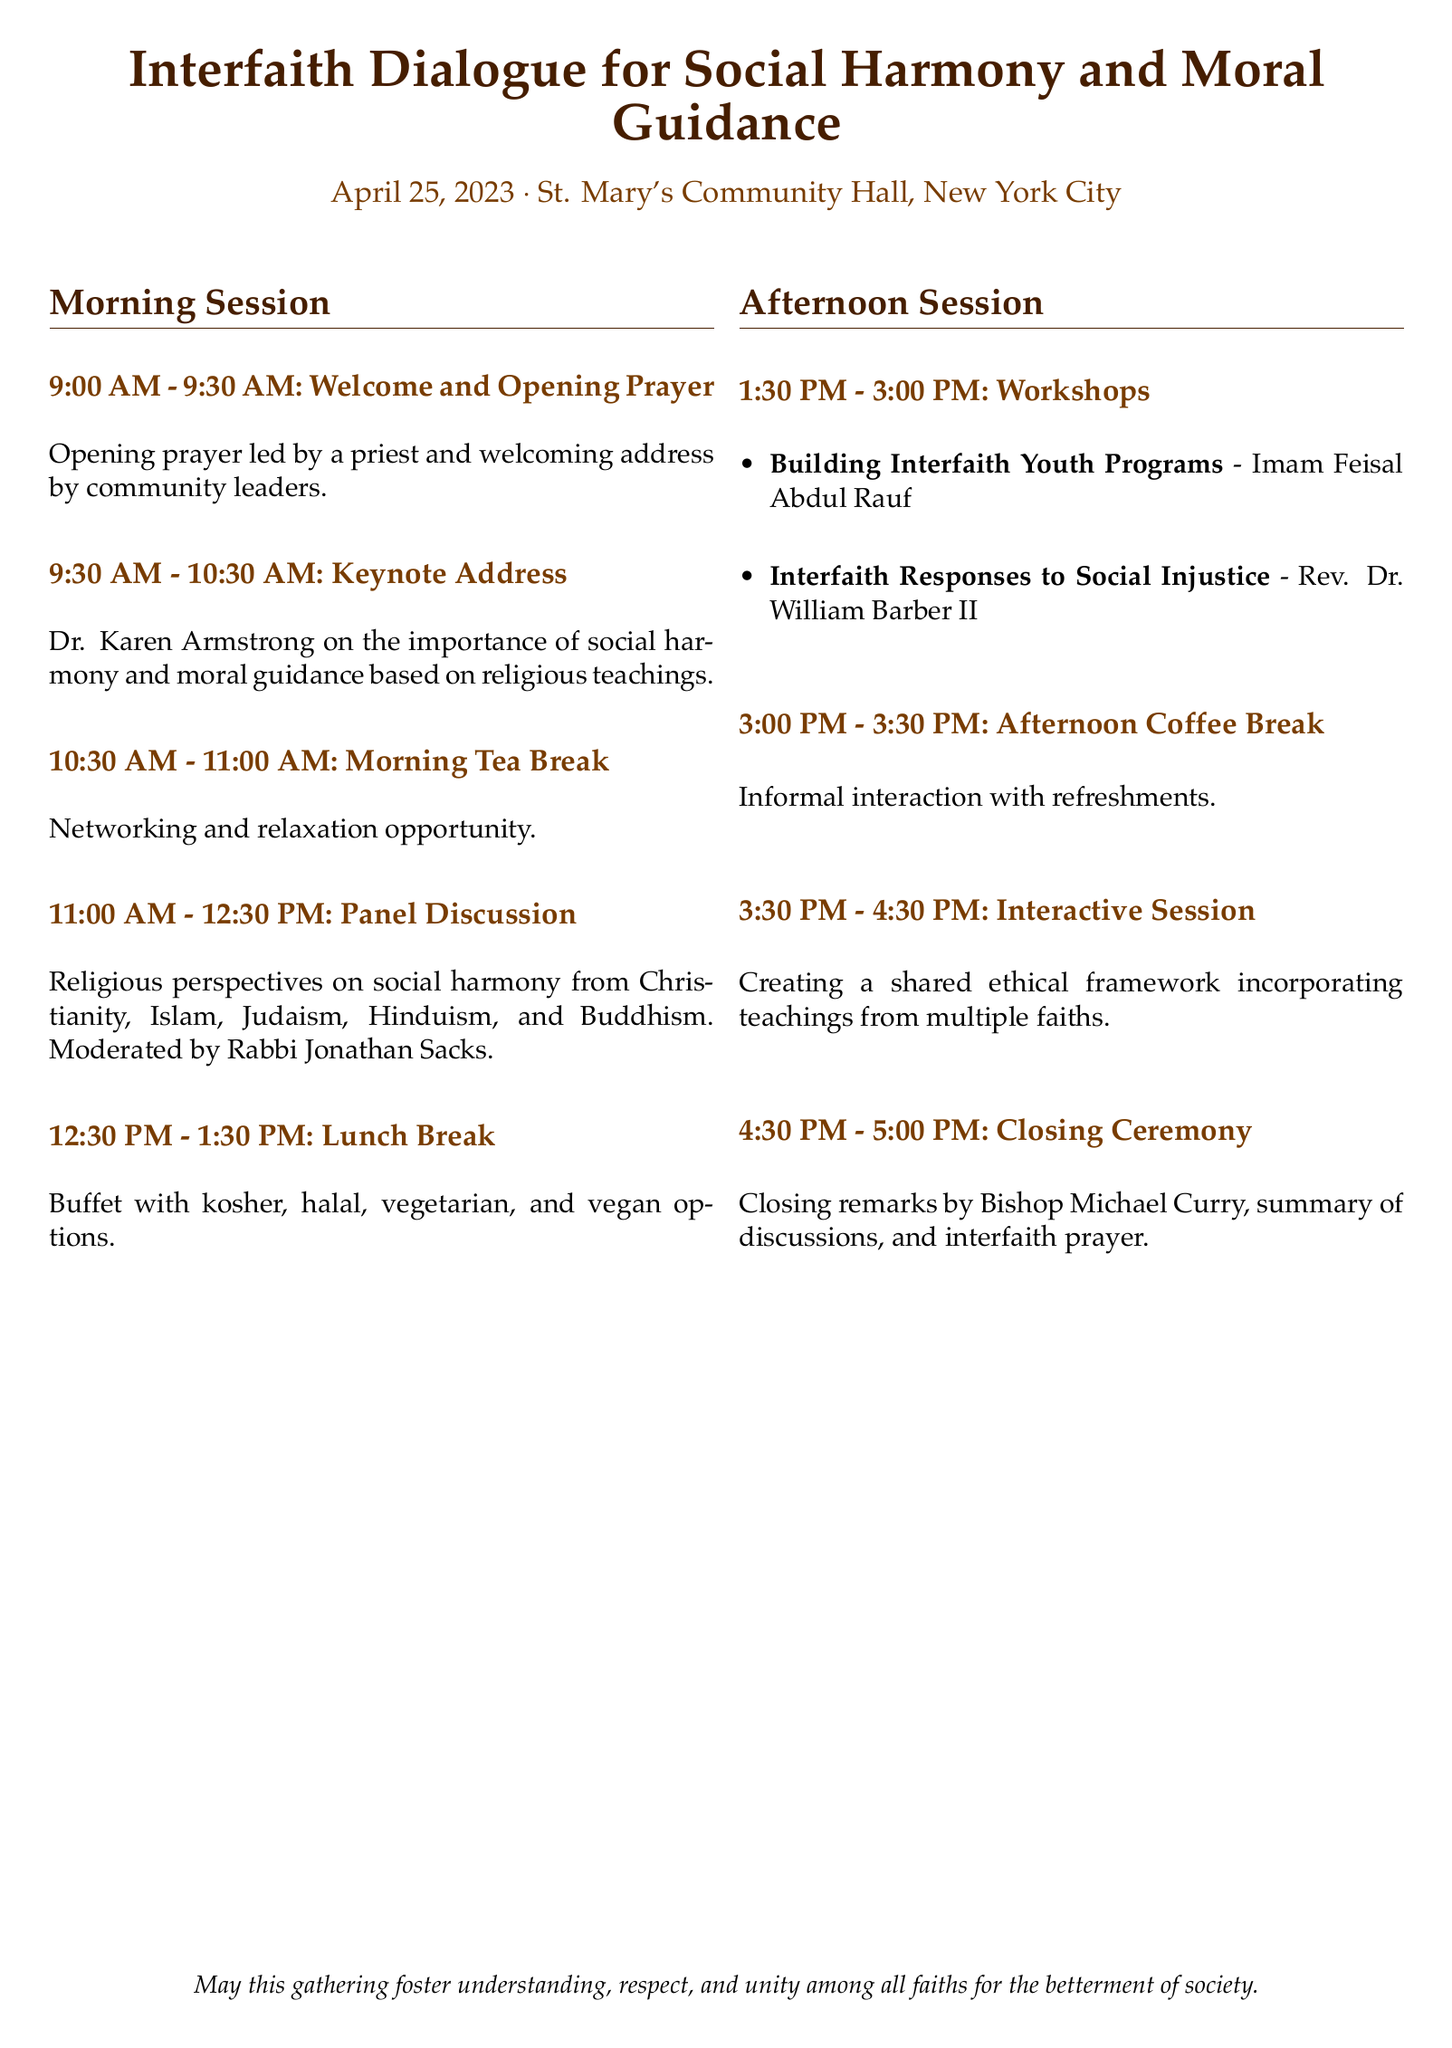What is the date of the event? The date of the event is clearly stated in the document as April 25, 2023.
Answer: April 25, 2023 Who is giving the keynote address? The document specifically names Dr. Karen Armstrong as the speaker for the keynote address.
Answer: Dr. Karen Armstrong What time does the morning tea break start? The start time for the morning tea break can be found in the schedule as 10:30 AM.
Answer: 10:30 AM How many workshops are scheduled for the afternoon session? The document mentions two workshops scheduled in the afternoon session.
Answer: Two Who is moderating the panel discussion? The panel discussion is moderated by Rabbi Jonathan Sacks, as indicated in the itinerary.
Answer: Rabbi Jonathan Sacks What is the main focus of the interactive session? The focus of the interactive session is about creating a shared ethical framework, as stated in the document.
Answer: Creating a shared ethical framework What types of food are offered during the lunch break? The document lists the types of food options available during lunch as kosher, halal, vegetarian, and vegan.
Answer: Kosher, halal, vegetarian, vegan Who is delivering the closing remarks? The document identifies Bishop Michael Curry as the person delivering the closing remarks during the closing ceremony.
Answer: Bishop Michael Curry 